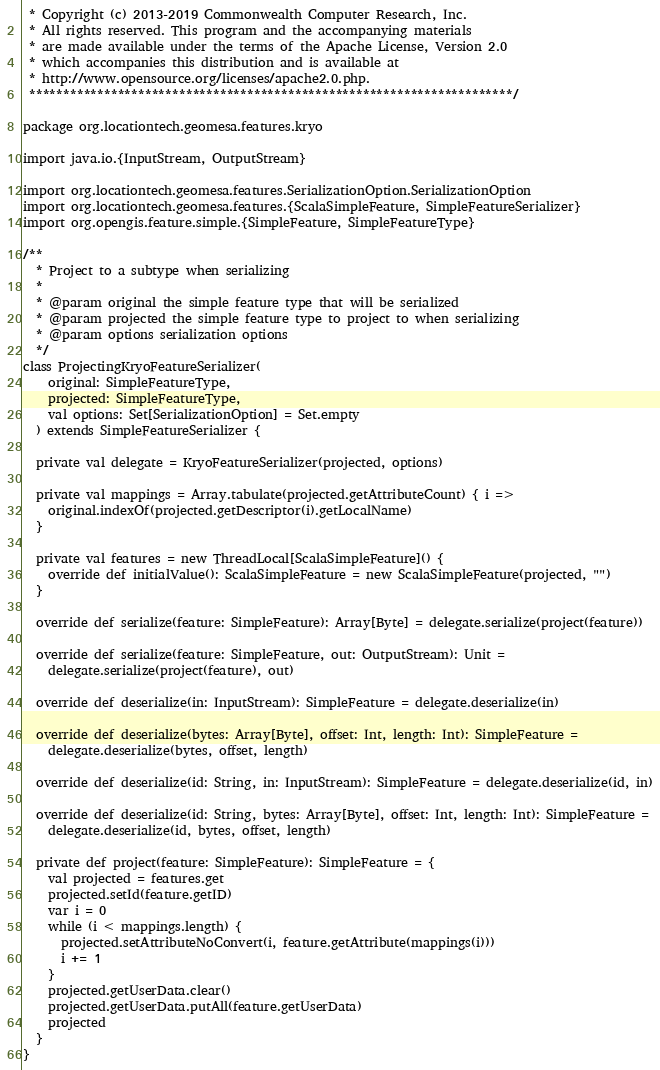Convert code to text. <code><loc_0><loc_0><loc_500><loc_500><_Scala_> * Copyright (c) 2013-2019 Commonwealth Computer Research, Inc.
 * All rights reserved. This program and the accompanying materials
 * are made available under the terms of the Apache License, Version 2.0
 * which accompanies this distribution and is available at
 * http://www.opensource.org/licenses/apache2.0.php.
 ***********************************************************************/

package org.locationtech.geomesa.features.kryo

import java.io.{InputStream, OutputStream}

import org.locationtech.geomesa.features.SerializationOption.SerializationOption
import org.locationtech.geomesa.features.{ScalaSimpleFeature, SimpleFeatureSerializer}
import org.opengis.feature.simple.{SimpleFeature, SimpleFeatureType}

/**
  * Project to a subtype when serializing
  *
  * @param original the simple feature type that will be serialized
  * @param projected the simple feature type to project to when serializing
  * @param options serialization options
  */
class ProjectingKryoFeatureSerializer(
    original: SimpleFeatureType,
    projected: SimpleFeatureType,
    val options: Set[SerializationOption] = Set.empty
  ) extends SimpleFeatureSerializer {

  private val delegate = KryoFeatureSerializer(projected, options)

  private val mappings = Array.tabulate(projected.getAttributeCount) { i =>
    original.indexOf(projected.getDescriptor(i).getLocalName)
  }

  private val features = new ThreadLocal[ScalaSimpleFeature]() {
    override def initialValue(): ScalaSimpleFeature = new ScalaSimpleFeature(projected, "")
  }

  override def serialize(feature: SimpleFeature): Array[Byte] = delegate.serialize(project(feature))

  override def serialize(feature: SimpleFeature, out: OutputStream): Unit =
    delegate.serialize(project(feature), out)

  override def deserialize(in: InputStream): SimpleFeature = delegate.deserialize(in)

  override def deserialize(bytes: Array[Byte], offset: Int, length: Int): SimpleFeature =
    delegate.deserialize(bytes, offset, length)

  override def deserialize(id: String, in: InputStream): SimpleFeature = delegate.deserialize(id, in)

  override def deserialize(id: String, bytes: Array[Byte], offset: Int, length: Int): SimpleFeature =
    delegate.deserialize(id, bytes, offset, length)

  private def project(feature: SimpleFeature): SimpleFeature = {
    val projected = features.get
    projected.setId(feature.getID)
    var i = 0
    while (i < mappings.length) {
      projected.setAttributeNoConvert(i, feature.getAttribute(mappings(i)))
      i += 1
    }
    projected.getUserData.clear()
    projected.getUserData.putAll(feature.getUserData)
    projected
  }
}
</code> 